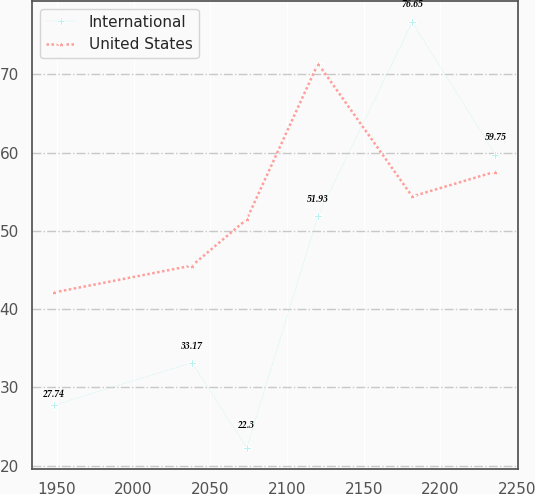Convert chart to OTSL. <chart><loc_0><loc_0><loc_500><loc_500><line_chart><ecel><fcel>International<fcel>United States<nl><fcel>1948.2<fcel>27.74<fcel>42.14<nl><fcel>2038.11<fcel>33.17<fcel>45.57<nl><fcel>2073.77<fcel>22.3<fcel>51.48<nl><fcel>2120.21<fcel>51.93<fcel>71.37<nl><fcel>2181.58<fcel>76.65<fcel>54.4<nl><fcel>2235.83<fcel>59.75<fcel>57.57<nl></chart> 